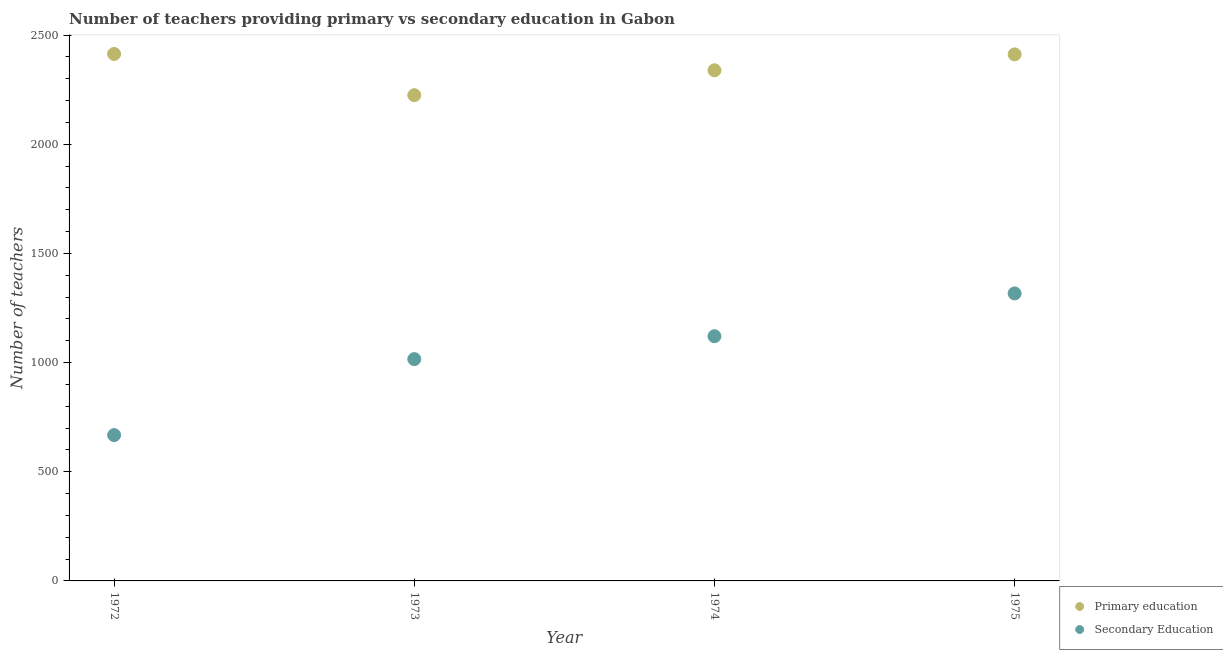How many different coloured dotlines are there?
Provide a short and direct response. 2. What is the number of primary teachers in 1973?
Provide a succinct answer. 2225. Across all years, what is the maximum number of primary teachers?
Your answer should be very brief. 2414. Across all years, what is the minimum number of primary teachers?
Offer a very short reply. 2225. In which year was the number of primary teachers maximum?
Ensure brevity in your answer.  1972. In which year was the number of primary teachers minimum?
Provide a short and direct response. 1973. What is the total number of secondary teachers in the graph?
Make the answer very short. 4122. What is the difference between the number of primary teachers in 1973 and that in 1974?
Offer a very short reply. -114. What is the difference between the number of primary teachers in 1975 and the number of secondary teachers in 1973?
Provide a short and direct response. 1396. What is the average number of secondary teachers per year?
Your answer should be compact. 1030.5. In the year 1972, what is the difference between the number of secondary teachers and number of primary teachers?
Offer a very short reply. -1746. What is the ratio of the number of primary teachers in 1973 to that in 1974?
Give a very brief answer. 0.95. What is the difference between the highest and the second highest number of secondary teachers?
Provide a succinct answer. 196. What is the difference between the highest and the lowest number of secondary teachers?
Make the answer very short. 649. Is the sum of the number of primary teachers in 1974 and 1975 greater than the maximum number of secondary teachers across all years?
Ensure brevity in your answer.  Yes. Does the number of primary teachers monotonically increase over the years?
Make the answer very short. No. Is the number of primary teachers strictly greater than the number of secondary teachers over the years?
Your answer should be very brief. Yes. Is the number of secondary teachers strictly less than the number of primary teachers over the years?
Provide a short and direct response. Yes. How many dotlines are there?
Your answer should be compact. 2. How many years are there in the graph?
Your response must be concise. 4. Are the values on the major ticks of Y-axis written in scientific E-notation?
Offer a terse response. No. How many legend labels are there?
Offer a very short reply. 2. What is the title of the graph?
Make the answer very short. Number of teachers providing primary vs secondary education in Gabon. What is the label or title of the Y-axis?
Your answer should be compact. Number of teachers. What is the Number of teachers of Primary education in 1972?
Your response must be concise. 2414. What is the Number of teachers in Secondary Education in 1972?
Your answer should be very brief. 668. What is the Number of teachers of Primary education in 1973?
Provide a short and direct response. 2225. What is the Number of teachers in Secondary Education in 1973?
Provide a succinct answer. 1016. What is the Number of teachers of Primary education in 1974?
Make the answer very short. 2339. What is the Number of teachers of Secondary Education in 1974?
Offer a very short reply. 1121. What is the Number of teachers in Primary education in 1975?
Provide a short and direct response. 2412. What is the Number of teachers of Secondary Education in 1975?
Your answer should be very brief. 1317. Across all years, what is the maximum Number of teachers in Primary education?
Make the answer very short. 2414. Across all years, what is the maximum Number of teachers of Secondary Education?
Your response must be concise. 1317. Across all years, what is the minimum Number of teachers in Primary education?
Keep it short and to the point. 2225. Across all years, what is the minimum Number of teachers of Secondary Education?
Offer a terse response. 668. What is the total Number of teachers in Primary education in the graph?
Offer a very short reply. 9390. What is the total Number of teachers in Secondary Education in the graph?
Provide a short and direct response. 4122. What is the difference between the Number of teachers of Primary education in 1972 and that in 1973?
Ensure brevity in your answer.  189. What is the difference between the Number of teachers in Secondary Education in 1972 and that in 1973?
Provide a succinct answer. -348. What is the difference between the Number of teachers in Primary education in 1972 and that in 1974?
Your answer should be very brief. 75. What is the difference between the Number of teachers in Secondary Education in 1972 and that in 1974?
Offer a terse response. -453. What is the difference between the Number of teachers in Secondary Education in 1972 and that in 1975?
Keep it short and to the point. -649. What is the difference between the Number of teachers in Primary education in 1973 and that in 1974?
Make the answer very short. -114. What is the difference between the Number of teachers in Secondary Education in 1973 and that in 1974?
Offer a very short reply. -105. What is the difference between the Number of teachers in Primary education in 1973 and that in 1975?
Your answer should be compact. -187. What is the difference between the Number of teachers of Secondary Education in 1973 and that in 1975?
Make the answer very short. -301. What is the difference between the Number of teachers in Primary education in 1974 and that in 1975?
Your answer should be compact. -73. What is the difference between the Number of teachers of Secondary Education in 1974 and that in 1975?
Make the answer very short. -196. What is the difference between the Number of teachers in Primary education in 1972 and the Number of teachers in Secondary Education in 1973?
Make the answer very short. 1398. What is the difference between the Number of teachers of Primary education in 1972 and the Number of teachers of Secondary Education in 1974?
Ensure brevity in your answer.  1293. What is the difference between the Number of teachers of Primary education in 1972 and the Number of teachers of Secondary Education in 1975?
Your answer should be compact. 1097. What is the difference between the Number of teachers of Primary education in 1973 and the Number of teachers of Secondary Education in 1974?
Offer a terse response. 1104. What is the difference between the Number of teachers of Primary education in 1973 and the Number of teachers of Secondary Education in 1975?
Offer a terse response. 908. What is the difference between the Number of teachers in Primary education in 1974 and the Number of teachers in Secondary Education in 1975?
Provide a short and direct response. 1022. What is the average Number of teachers of Primary education per year?
Offer a very short reply. 2347.5. What is the average Number of teachers of Secondary Education per year?
Make the answer very short. 1030.5. In the year 1972, what is the difference between the Number of teachers of Primary education and Number of teachers of Secondary Education?
Your answer should be compact. 1746. In the year 1973, what is the difference between the Number of teachers in Primary education and Number of teachers in Secondary Education?
Make the answer very short. 1209. In the year 1974, what is the difference between the Number of teachers of Primary education and Number of teachers of Secondary Education?
Give a very brief answer. 1218. In the year 1975, what is the difference between the Number of teachers in Primary education and Number of teachers in Secondary Education?
Provide a short and direct response. 1095. What is the ratio of the Number of teachers of Primary education in 1972 to that in 1973?
Make the answer very short. 1.08. What is the ratio of the Number of teachers of Secondary Education in 1972 to that in 1973?
Offer a very short reply. 0.66. What is the ratio of the Number of teachers of Primary education in 1972 to that in 1974?
Your answer should be compact. 1.03. What is the ratio of the Number of teachers of Secondary Education in 1972 to that in 1974?
Give a very brief answer. 0.6. What is the ratio of the Number of teachers of Secondary Education in 1972 to that in 1975?
Your answer should be very brief. 0.51. What is the ratio of the Number of teachers of Primary education in 1973 to that in 1974?
Provide a short and direct response. 0.95. What is the ratio of the Number of teachers in Secondary Education in 1973 to that in 1974?
Offer a terse response. 0.91. What is the ratio of the Number of teachers in Primary education in 1973 to that in 1975?
Your answer should be very brief. 0.92. What is the ratio of the Number of teachers in Secondary Education in 1973 to that in 1975?
Provide a short and direct response. 0.77. What is the ratio of the Number of teachers in Primary education in 1974 to that in 1975?
Give a very brief answer. 0.97. What is the ratio of the Number of teachers of Secondary Education in 1974 to that in 1975?
Provide a succinct answer. 0.85. What is the difference between the highest and the second highest Number of teachers in Primary education?
Provide a short and direct response. 2. What is the difference between the highest and the second highest Number of teachers of Secondary Education?
Give a very brief answer. 196. What is the difference between the highest and the lowest Number of teachers in Primary education?
Offer a very short reply. 189. What is the difference between the highest and the lowest Number of teachers in Secondary Education?
Make the answer very short. 649. 